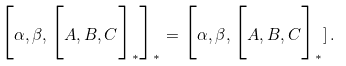Convert formula to latex. <formula><loc_0><loc_0><loc_500><loc_500>\Big [ \alpha , \beta , \Big [ A , B , C \Big ] _ { * } \Big ] _ { * } = \Big [ \alpha , \beta , \Big [ A , B , C \Big ] _ { * } ] \, .</formula> 